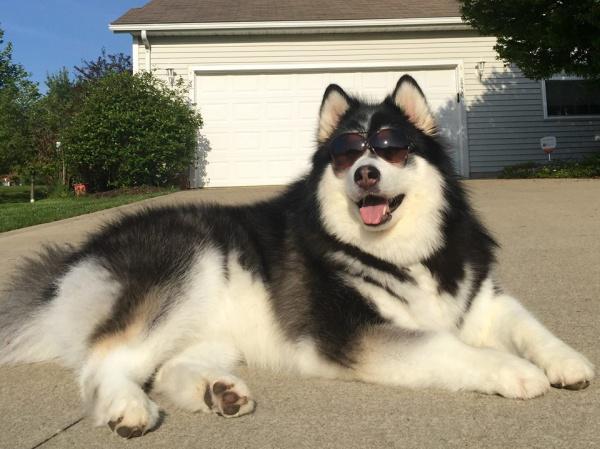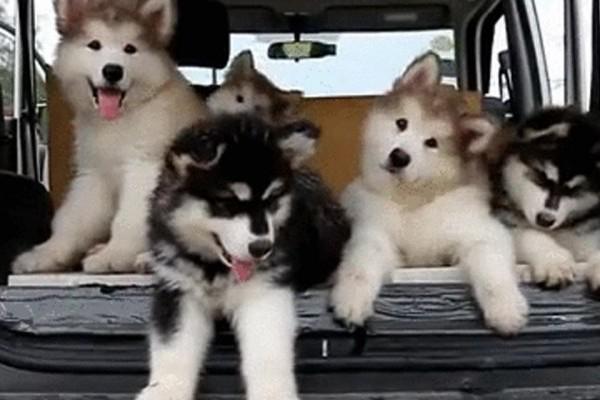The first image is the image on the left, the second image is the image on the right. Analyze the images presented: Is the assertion "There are at most three puppies in the image pair." valid? Answer yes or no. No. 